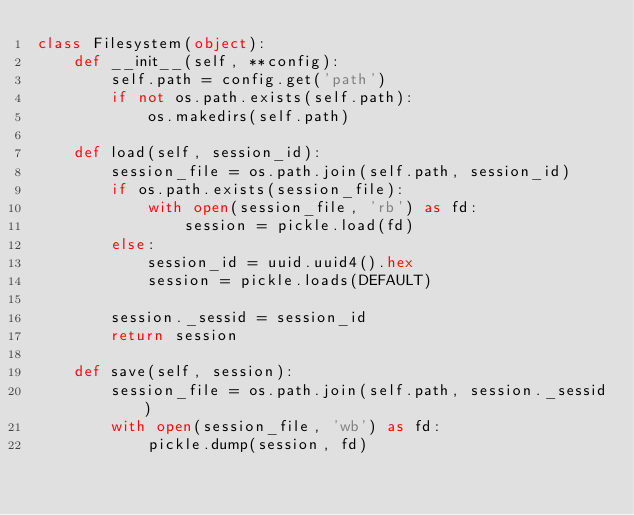Convert code to text. <code><loc_0><loc_0><loc_500><loc_500><_Python_>class Filesystem(object):
    def __init__(self, **config):
        self.path = config.get('path')
        if not os.path.exists(self.path):
            os.makedirs(self.path)

    def load(self, session_id):
        session_file = os.path.join(self.path, session_id)
        if os.path.exists(session_file):
            with open(session_file, 'rb') as fd:
                session = pickle.load(fd)
        else:
            session_id = uuid.uuid4().hex
            session = pickle.loads(DEFAULT)

        session._sessid = session_id
        return session

    def save(self, session):
        session_file = os.path.join(self.path, session._sessid)
        with open(session_file, 'wb') as fd:
            pickle.dump(session, fd)
</code> 